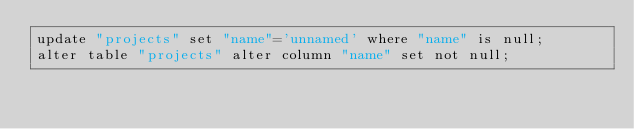<code> <loc_0><loc_0><loc_500><loc_500><_SQL_>update "projects" set "name"='unnamed' where "name" is null;
alter table "projects" alter column "name" set not null;
</code> 